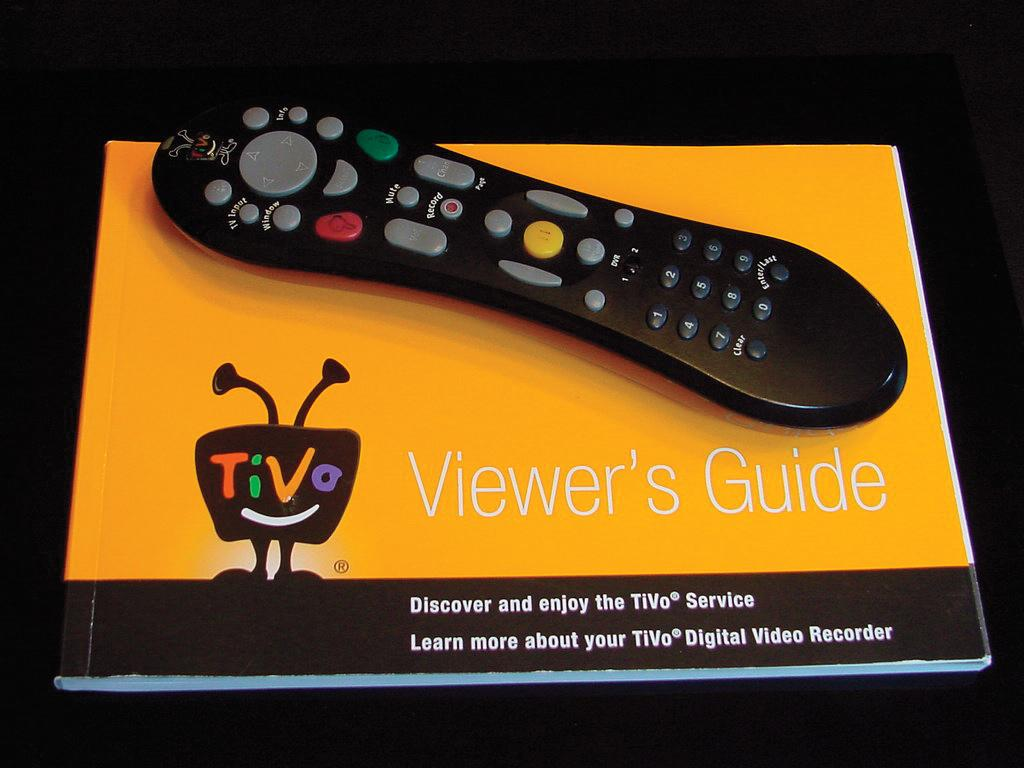What is the main object in the image? There is a book in the image. What is the title of the book? The name of the book is "viewers guide". What other object is placed on the book? There is a remote on the book. What type of advice can be found in the ocean according to the book in the image? There is no mention of the ocean or advice in the image or the book's title. 